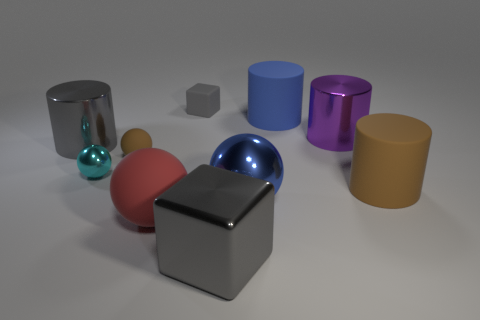Subtract 1 balls. How many balls are left? 3 Subtract all brown cylinders. How many cylinders are left? 3 Subtract all green spheres. Subtract all purple cylinders. How many spheres are left? 4 Subtract all cubes. How many objects are left? 8 Add 3 large matte cylinders. How many large matte cylinders are left? 5 Add 1 brown balls. How many brown balls exist? 2 Subtract 1 brown spheres. How many objects are left? 9 Subtract all gray rubber objects. Subtract all purple metal cylinders. How many objects are left? 8 